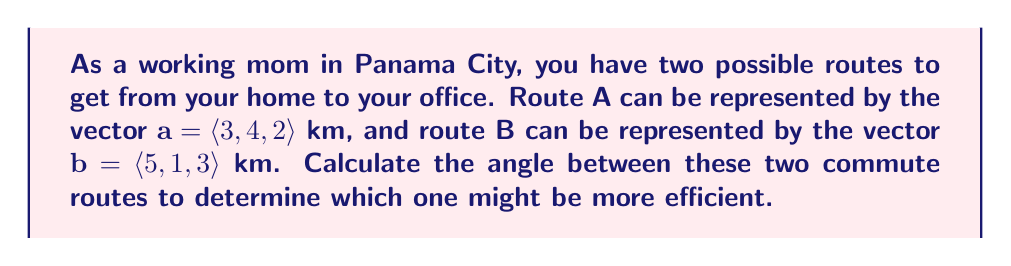Teach me how to tackle this problem. To find the angle between two vectors, we can use the dot product formula:

$$\cos \theta = \frac{\mathbf{a} \cdot \mathbf{b}}{|\mathbf{a}||\mathbf{b}|}$$

Where $\theta$ is the angle between the vectors, $\mathbf{a} \cdot \mathbf{b}$ is the dot product of the vectors, and $|\mathbf{a}|$ and $|\mathbf{b}|$ are the magnitudes of vectors $\mathbf{a}$ and $\mathbf{b}$ respectively.

Step 1: Calculate the dot product $\mathbf{a} \cdot \mathbf{b}$
$$\mathbf{a} \cdot \mathbf{b} = (3)(5) + (4)(1) + (2)(3) = 15 + 4 + 6 = 25$$

Step 2: Calculate the magnitudes of $\mathbf{a}$ and $\mathbf{b}$
$$|\mathbf{a}| = \sqrt{3^2 + 4^2 + 2^2} = \sqrt{9 + 16 + 4} = \sqrt{29}$$
$$|\mathbf{b}| = \sqrt{5^2 + 1^2 + 3^2} = \sqrt{25 + 1 + 9} = \sqrt{35}$$

Step 3: Substitute the values into the formula
$$\cos \theta = \frac{25}{\sqrt{29}\sqrt{35}}$$

Step 4: Solve for $\theta$ using the inverse cosine function
$$\theta = \arccos\left(\frac{25}{\sqrt{29}\sqrt{35}}\right)$$

Step 5: Calculate the result (rounded to two decimal places)
$$\theta \approx 0.40 \text{ radians}$$

Convert to degrees:
$$\theta \approx 0.40 \times \frac{180°}{\pi} \approx 22.92°$$
Answer: The angle between the two commute routes is approximately $22.92°$ or $0.40$ radians. 